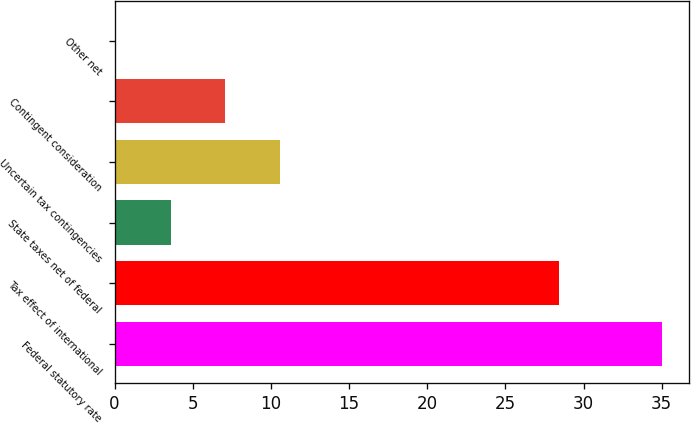Convert chart. <chart><loc_0><loc_0><loc_500><loc_500><bar_chart><fcel>Federal statutory rate<fcel>Tax effect of international<fcel>State taxes net of federal<fcel>Uncertain tax contingencies<fcel>Contingent consideration<fcel>Other net<nl><fcel>35<fcel>28.4<fcel>3.59<fcel>10.57<fcel>7.08<fcel>0.1<nl></chart> 